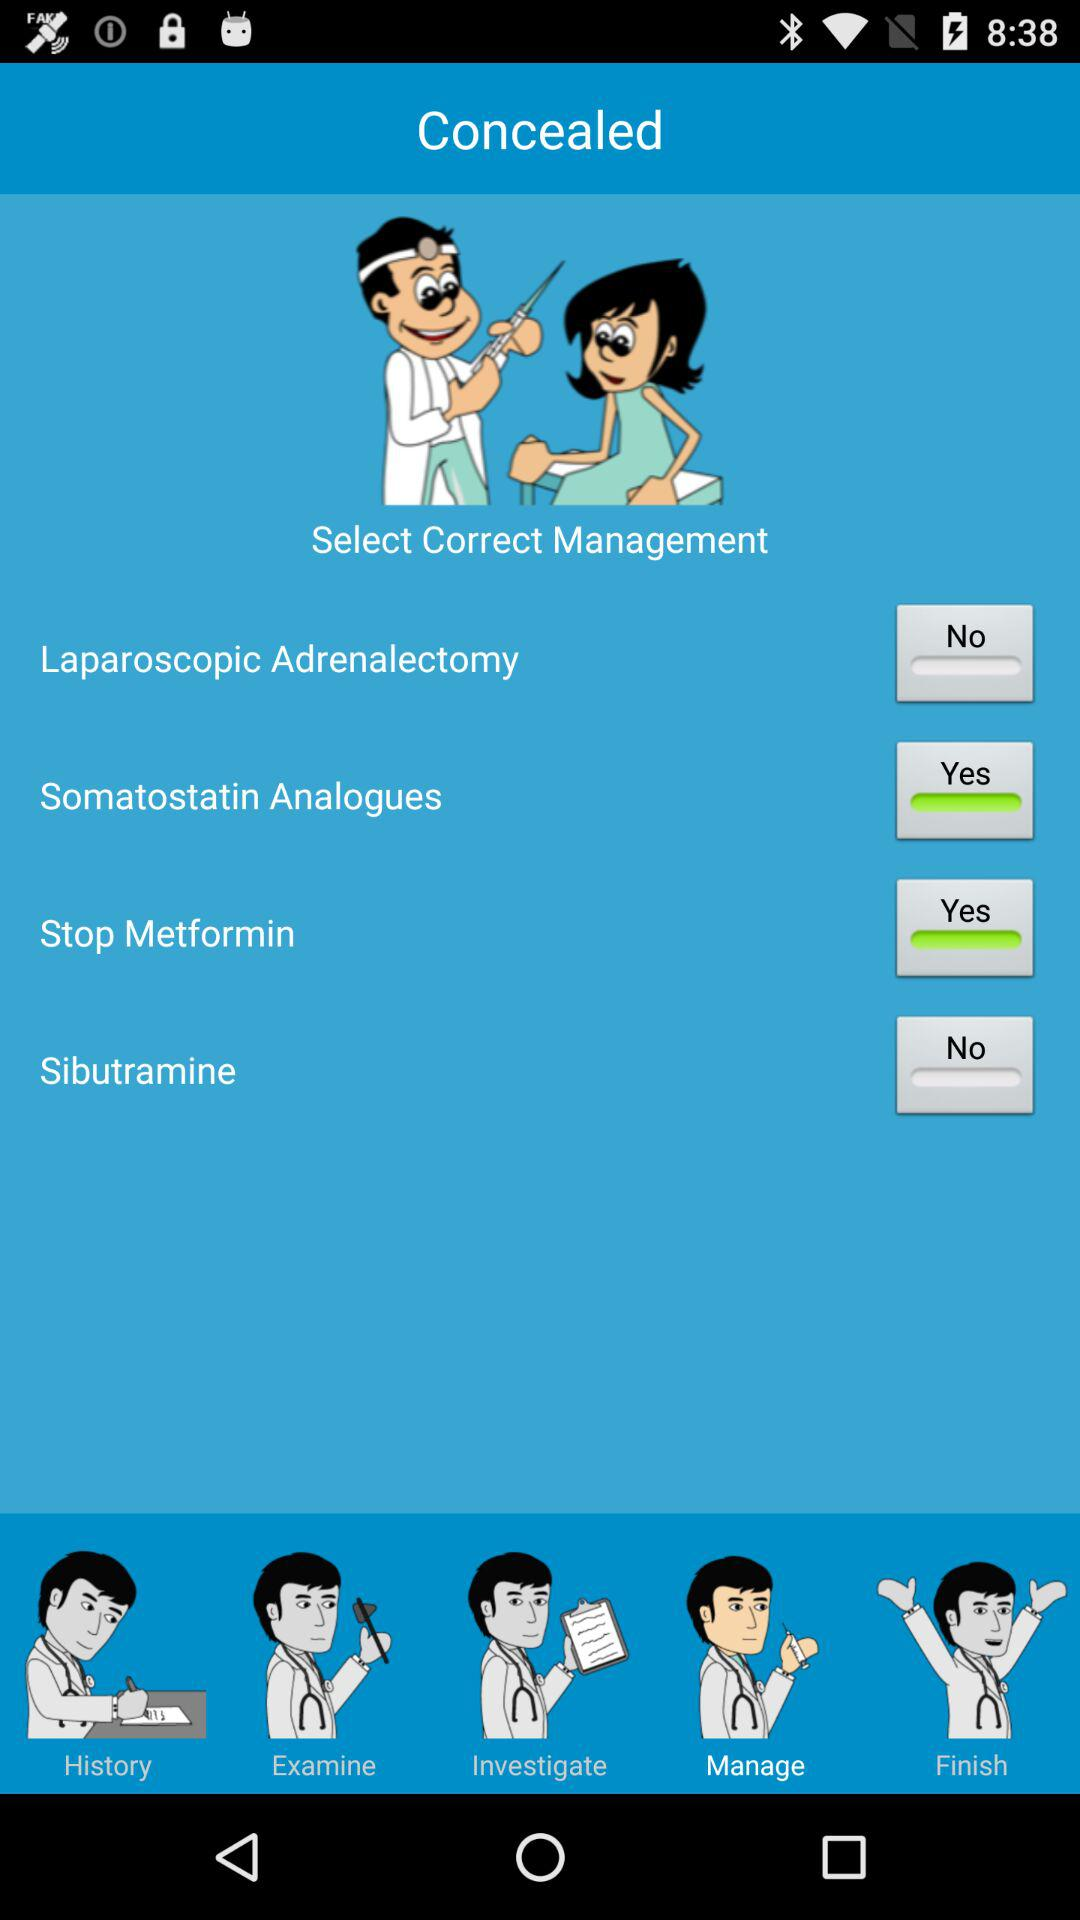How many management options are available?
Answer the question using a single word or phrase. 4 